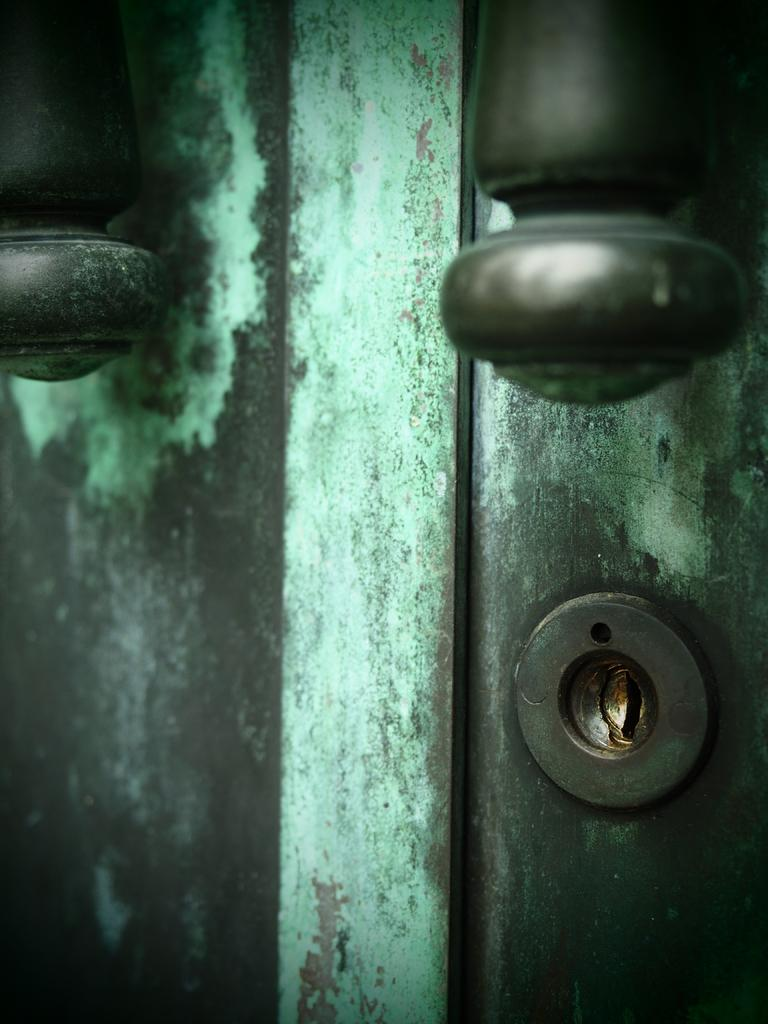What is the main subject of the image? The main subject of the image is a door. What feature is present on the door that allows it to be opened and closed? There are handles on the door. How can the door be secured when not in use? There is a lock on the door. Are there any fairies visible on the door in the image? There are no fairies present in the image; it is a picture of a door with handles and a lock. 